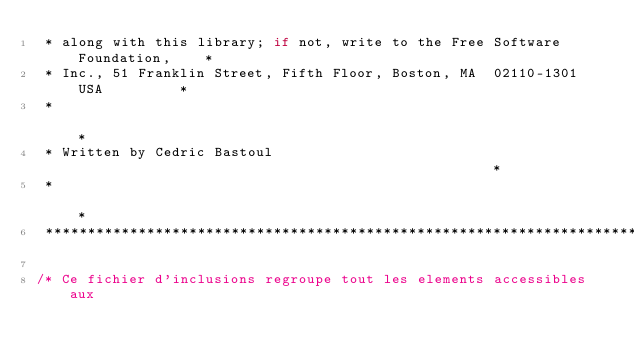<code> <loc_0><loc_0><loc_500><loc_500><_C_> * along with this library; if not, write to the Free Software Foundation,    *
 * Inc., 51 Franklin Street, Fifth Floor, Boston, MA  02110-1301  USA         *
 *                                                                            *
 * Written by Cedric Bastoul                                                  *
 *                                                                            *
 ******************************************************************************/

/* Ce fichier d'inclusions regroupe tout les elements accessibles aux</code> 